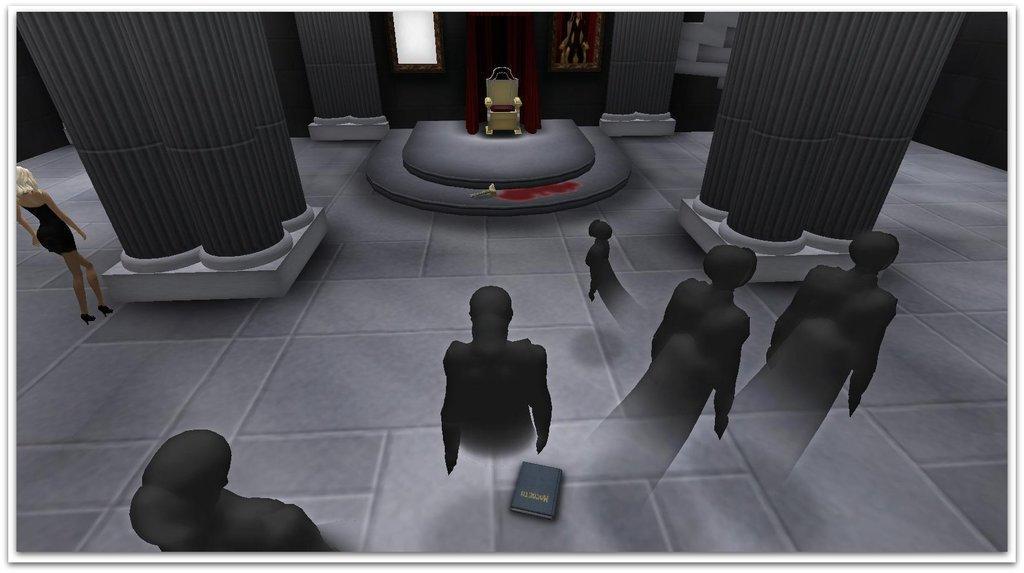Please provide a concise description of this image. In this picture we can observe graphics. There are pillars and a chair which is in yellow color and the pillars are in grey color. On the left side there is a woman. We can observe some shadows which are in black color. 